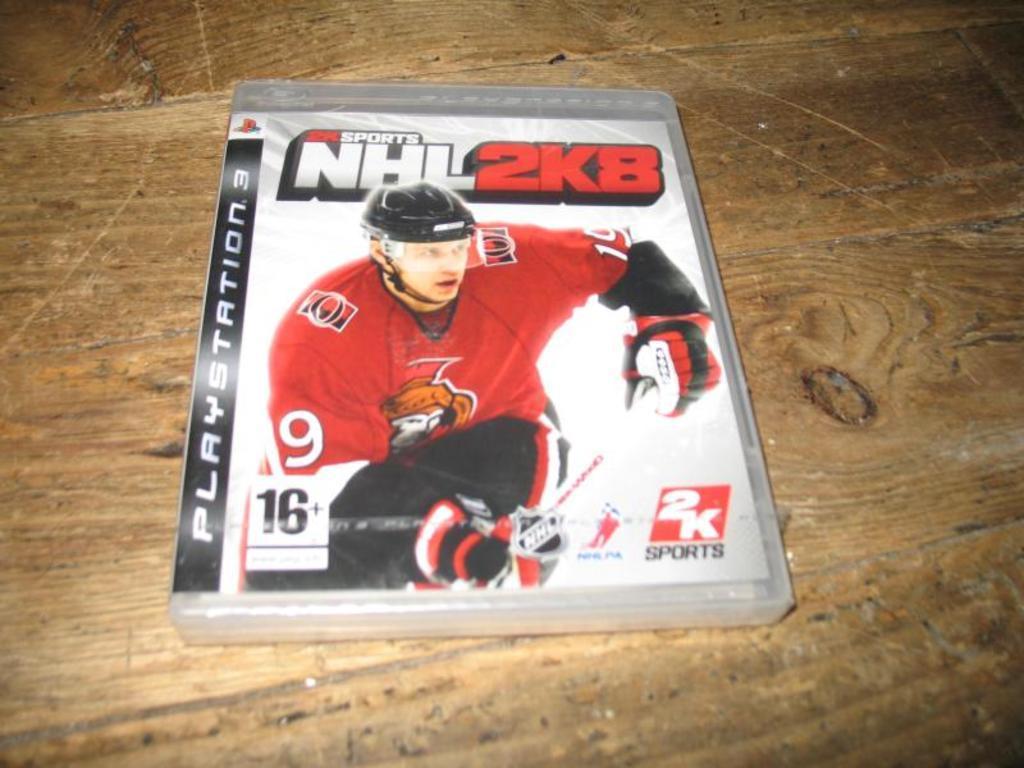Please provide a concise description of this image. In this image, I think this is a DVD case. I can see the picture of the man and letters. This looks like a wooden board. 